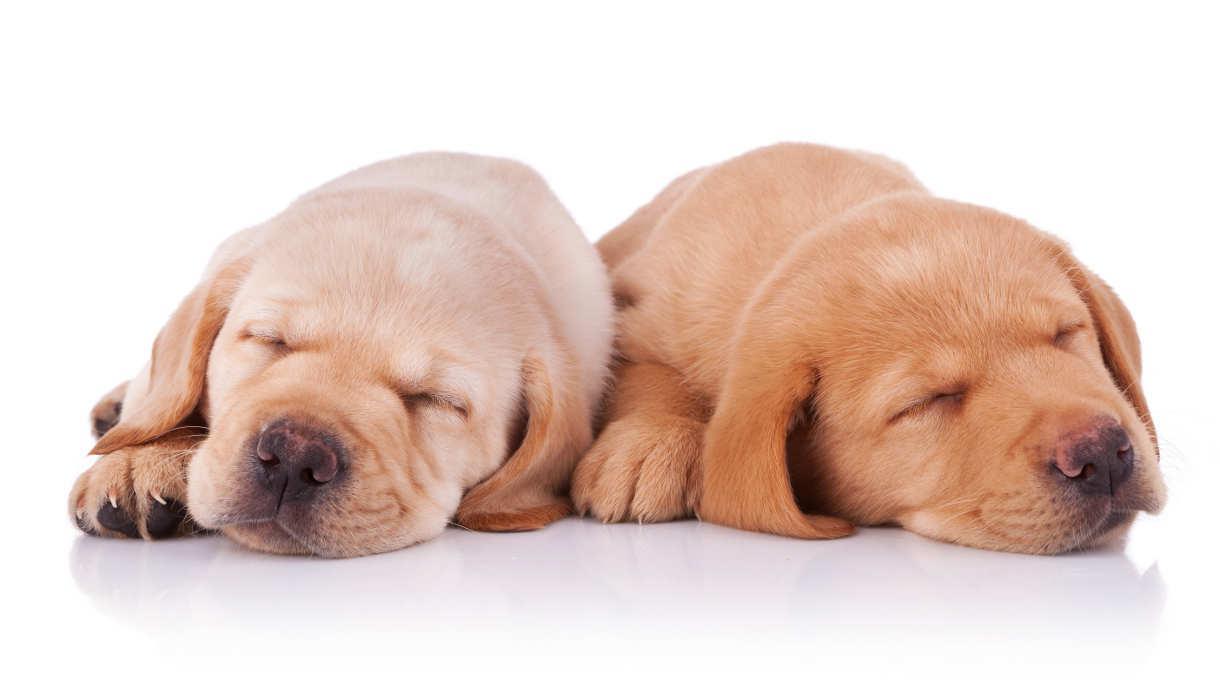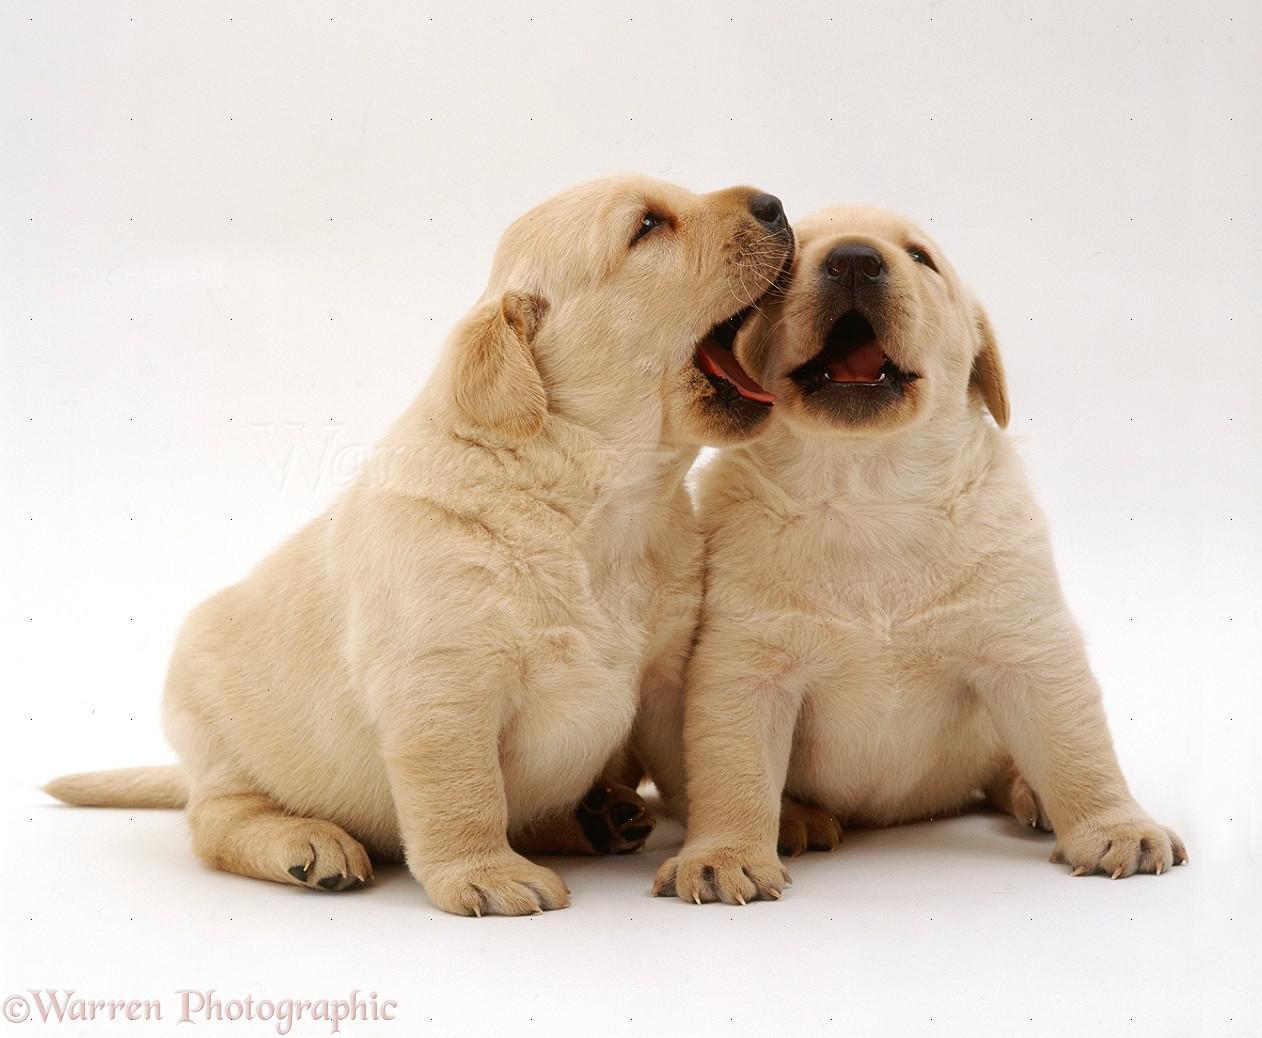The first image is the image on the left, the second image is the image on the right. For the images displayed, is the sentence "A puppy has a paw around a dark brownish-gray puppy that is reclining." factually correct? Answer yes or no. No. The first image is the image on the left, the second image is the image on the right. For the images shown, is this caption "Two dogs are lying down in the image on the left." true? Answer yes or no. Yes. 